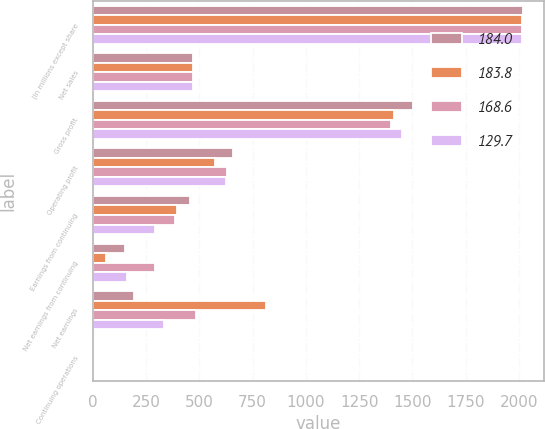Convert chart to OTSL. <chart><loc_0><loc_0><loc_500><loc_500><stacked_bar_chart><ecel><fcel>(In millions except share<fcel>Net sales<fcel>Gross profit<fcel>Operating profit<fcel>Earnings from continuing<fcel>Net earnings from continuing<fcel>Net earnings<fcel>Continuing operations<nl><fcel>184<fcel>2018<fcel>472.1<fcel>1502.1<fcel>656.3<fcel>457.8<fcel>150.3<fcel>193.1<fcel>0.94<nl><fcel>183.8<fcel>2017<fcel>472.1<fcel>1412.1<fcel>571.3<fcel>393.3<fcel>62.8<fcel>814.9<fcel>0.34<nl><fcel>168.6<fcel>2016<fcel>472.1<fcel>1401<fcel>628.9<fcel>387.9<fcel>292.3<fcel>486.4<fcel>1.5<nl><fcel>129.7<fcel>2015<fcel>472.1<fcel>1449.2<fcel>624.9<fcel>291.4<fcel>158.8<fcel>335.4<fcel>0.78<nl></chart> 